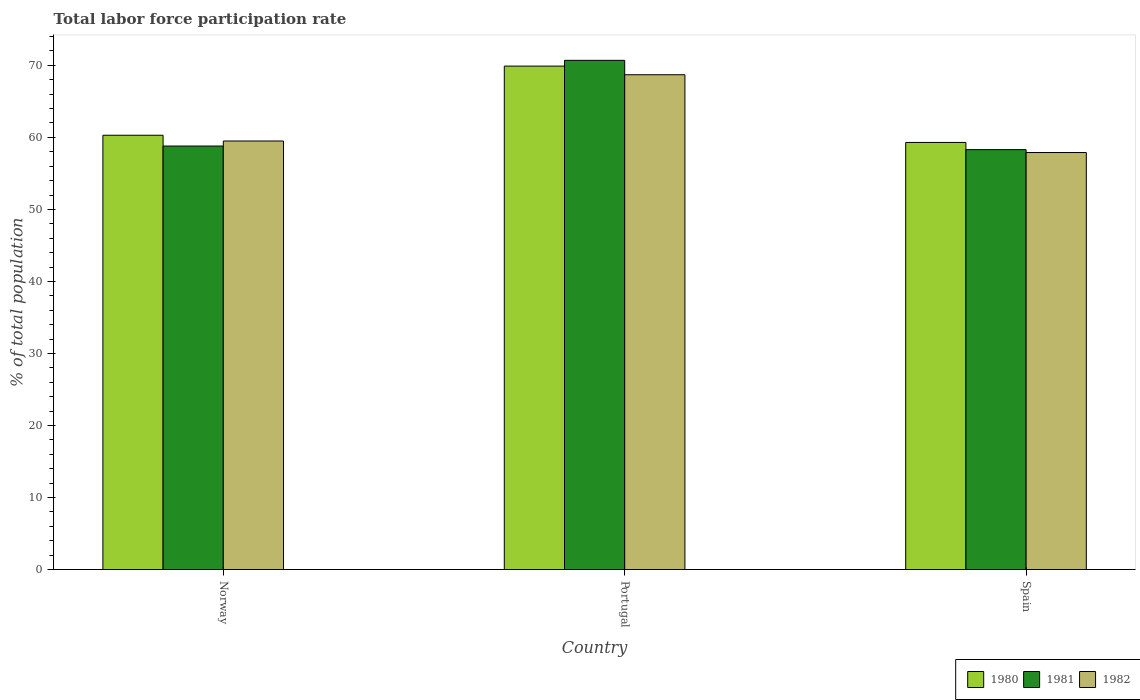How many different coloured bars are there?
Offer a very short reply. 3. Are the number of bars per tick equal to the number of legend labels?
Your response must be concise. Yes. What is the label of the 2nd group of bars from the left?
Your answer should be very brief. Portugal. In how many cases, is the number of bars for a given country not equal to the number of legend labels?
Keep it short and to the point. 0. What is the total labor force participation rate in 1980 in Spain?
Ensure brevity in your answer.  59.3. Across all countries, what is the maximum total labor force participation rate in 1982?
Give a very brief answer. 68.7. Across all countries, what is the minimum total labor force participation rate in 1981?
Make the answer very short. 58.3. In which country was the total labor force participation rate in 1982 minimum?
Your answer should be compact. Spain. What is the total total labor force participation rate in 1982 in the graph?
Keep it short and to the point. 186.1. What is the difference between the total labor force participation rate in 1981 in Portugal and that in Spain?
Give a very brief answer. 12.4. What is the difference between the total labor force participation rate in 1981 in Portugal and the total labor force participation rate in 1982 in Spain?
Offer a terse response. 12.8. What is the average total labor force participation rate in 1981 per country?
Offer a terse response. 62.6. What is the difference between the total labor force participation rate of/in 1982 and total labor force participation rate of/in 1981 in Norway?
Give a very brief answer. 0.7. What is the ratio of the total labor force participation rate in 1982 in Portugal to that in Spain?
Give a very brief answer. 1.19. Is the total labor force participation rate in 1982 in Portugal less than that in Spain?
Give a very brief answer. No. What is the difference between the highest and the second highest total labor force participation rate in 1981?
Keep it short and to the point. 0.5. What is the difference between the highest and the lowest total labor force participation rate in 1980?
Provide a succinct answer. 10.6. In how many countries, is the total labor force participation rate in 1981 greater than the average total labor force participation rate in 1981 taken over all countries?
Provide a succinct answer. 1. What does the 1st bar from the left in Spain represents?
Provide a succinct answer. 1980. What does the 1st bar from the right in Portugal represents?
Provide a short and direct response. 1982. Are all the bars in the graph horizontal?
Your response must be concise. No. What is the difference between two consecutive major ticks on the Y-axis?
Make the answer very short. 10. Are the values on the major ticks of Y-axis written in scientific E-notation?
Offer a terse response. No. Does the graph contain grids?
Keep it short and to the point. No. What is the title of the graph?
Your answer should be compact. Total labor force participation rate. What is the label or title of the X-axis?
Your answer should be very brief. Country. What is the label or title of the Y-axis?
Your response must be concise. % of total population. What is the % of total population of 1980 in Norway?
Offer a terse response. 60.3. What is the % of total population of 1981 in Norway?
Provide a succinct answer. 58.8. What is the % of total population in 1982 in Norway?
Give a very brief answer. 59.5. What is the % of total population of 1980 in Portugal?
Make the answer very short. 69.9. What is the % of total population of 1981 in Portugal?
Keep it short and to the point. 70.7. What is the % of total population in 1982 in Portugal?
Keep it short and to the point. 68.7. What is the % of total population of 1980 in Spain?
Your answer should be compact. 59.3. What is the % of total population in 1981 in Spain?
Give a very brief answer. 58.3. What is the % of total population of 1982 in Spain?
Offer a very short reply. 57.9. Across all countries, what is the maximum % of total population in 1980?
Provide a short and direct response. 69.9. Across all countries, what is the maximum % of total population of 1981?
Your answer should be very brief. 70.7. Across all countries, what is the maximum % of total population in 1982?
Make the answer very short. 68.7. Across all countries, what is the minimum % of total population of 1980?
Your response must be concise. 59.3. Across all countries, what is the minimum % of total population of 1981?
Provide a short and direct response. 58.3. Across all countries, what is the minimum % of total population of 1982?
Make the answer very short. 57.9. What is the total % of total population in 1980 in the graph?
Ensure brevity in your answer.  189.5. What is the total % of total population of 1981 in the graph?
Keep it short and to the point. 187.8. What is the total % of total population in 1982 in the graph?
Make the answer very short. 186.1. What is the difference between the % of total population of 1980 in Norway and that in Spain?
Your response must be concise. 1. What is the difference between the % of total population in 1981 in Norway and that in Spain?
Your answer should be compact. 0.5. What is the difference between the % of total population in 1982 in Norway and that in Spain?
Keep it short and to the point. 1.6. What is the difference between the % of total population of 1982 in Portugal and that in Spain?
Offer a terse response. 10.8. What is the difference between the % of total population in 1980 in Norway and the % of total population in 1981 in Portugal?
Keep it short and to the point. -10.4. What is the difference between the % of total population in 1980 in Norway and the % of total population in 1982 in Portugal?
Make the answer very short. -8.4. What is the difference between the % of total population of 1981 in Norway and the % of total population of 1982 in Portugal?
Your answer should be compact. -9.9. What is the difference between the % of total population in 1980 in Norway and the % of total population in 1981 in Spain?
Make the answer very short. 2. What is the difference between the % of total population in 1980 in Norway and the % of total population in 1982 in Spain?
Your answer should be compact. 2.4. What is the difference between the % of total population in 1980 in Portugal and the % of total population in 1981 in Spain?
Give a very brief answer. 11.6. What is the difference between the % of total population of 1981 in Portugal and the % of total population of 1982 in Spain?
Ensure brevity in your answer.  12.8. What is the average % of total population of 1980 per country?
Make the answer very short. 63.17. What is the average % of total population of 1981 per country?
Offer a terse response. 62.6. What is the average % of total population of 1982 per country?
Keep it short and to the point. 62.03. What is the difference between the % of total population in 1980 and % of total population in 1982 in Norway?
Your response must be concise. 0.8. What is the difference between the % of total population of 1980 and % of total population of 1981 in Portugal?
Offer a very short reply. -0.8. What is the difference between the % of total population in 1980 and % of total population in 1982 in Portugal?
Provide a short and direct response. 1.2. What is the difference between the % of total population of 1981 and % of total population of 1982 in Portugal?
Your answer should be very brief. 2. What is the difference between the % of total population of 1980 and % of total population of 1982 in Spain?
Offer a very short reply. 1.4. What is the ratio of the % of total population of 1980 in Norway to that in Portugal?
Provide a succinct answer. 0.86. What is the ratio of the % of total population of 1981 in Norway to that in Portugal?
Give a very brief answer. 0.83. What is the ratio of the % of total population in 1982 in Norway to that in Portugal?
Provide a succinct answer. 0.87. What is the ratio of the % of total population of 1980 in Norway to that in Spain?
Offer a very short reply. 1.02. What is the ratio of the % of total population in 1981 in Norway to that in Spain?
Provide a short and direct response. 1.01. What is the ratio of the % of total population in 1982 in Norway to that in Spain?
Your answer should be very brief. 1.03. What is the ratio of the % of total population in 1980 in Portugal to that in Spain?
Your answer should be compact. 1.18. What is the ratio of the % of total population of 1981 in Portugal to that in Spain?
Ensure brevity in your answer.  1.21. What is the ratio of the % of total population in 1982 in Portugal to that in Spain?
Offer a terse response. 1.19. 